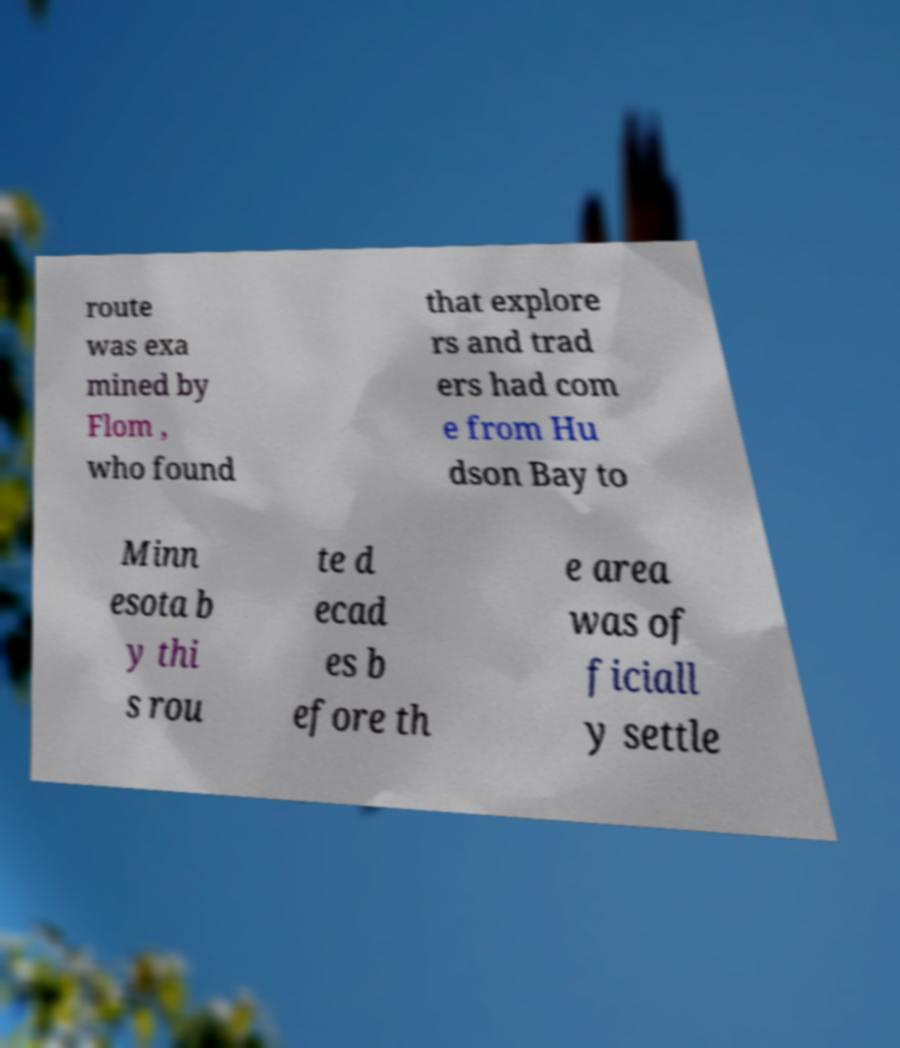Can you read and provide the text displayed in the image?This photo seems to have some interesting text. Can you extract and type it out for me? route was exa mined by Flom , who found that explore rs and trad ers had com e from Hu dson Bay to Minn esota b y thi s rou te d ecad es b efore th e area was of ficiall y settle 